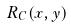<formula> <loc_0><loc_0><loc_500><loc_500>R _ { C } ( x , y )</formula> 